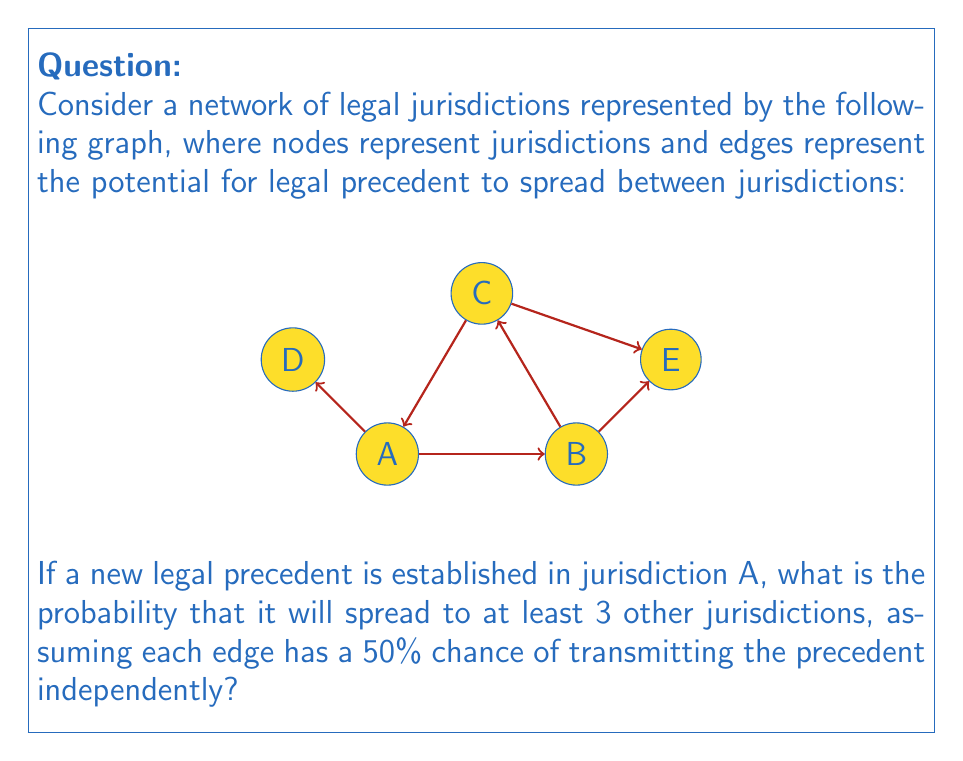Can you answer this question? To solve this problem, we need to consider the possible ways the legal precedent can spread through the network. Let's approach this step-by-step:

1) First, let's identify all possible paths from A to other jurisdictions:
   A → B, A → C, A → D
   A → B → E, A → C → E

2) Now, we need to calculate the probability of the precedent reaching at least 3 other jurisdictions. This is equivalent to the complement of the probability of reaching 0, 1, or 2 other jurisdictions.

3) Let's calculate these probabilities:
   P(reaching 0) = (1-0.5)^3 = 0.125
   
   P(reaching 1) = 
   $${3 \choose 1}(0.5)^1(0.5)^2 = 3 * 0.5 * 0.25 = 0.375$$
   
   P(reaching 2) = 
   $${3 \choose 2}(0.5)^2(0.5)^1 + {3 \choose 2}(0.5)^2(0.5)^2 = 3 * 0.25 * 0.5 + 3 * 0.25 * 0.25 = 0.375 + 0.1875 = 0.5625$$

4) The probability of reaching at least 3 is the complement of the sum of these probabilities:
   $$P(\text{at least 3}) = 1 - (P(0) + P(1) + P(2))$$
   $$= 1 - (0.125 + 0.375 + 0.5625)$$
   $$= 1 - 1.0625 = -0.0625$$

5) However, this negative probability doesn't make sense in the real world. The issue arises because we've double-counted some scenarios in step 3. For example, the case where the precedent spreads to B, C, and E is counted both in P(reaching 2) and P(reaching 3).

6) To correct this, we need to consider the exact probabilities:
   P(exactly 3) = 
   $$(0.5)^3(0.5) + (0.5)^3(0.5) = 0.0625 + 0.0625 = 0.125$$
   
   P(exactly 4) = 
   $$(0.5)^4 = 0.0625$$

7) Therefore, the correct probability of reaching at least 3 other jurisdictions is:
   $$P(\text{at least 3}) = P(3) + P(4) = 0.125 + 0.0625 = 0.1875$$
Answer: 0.1875 